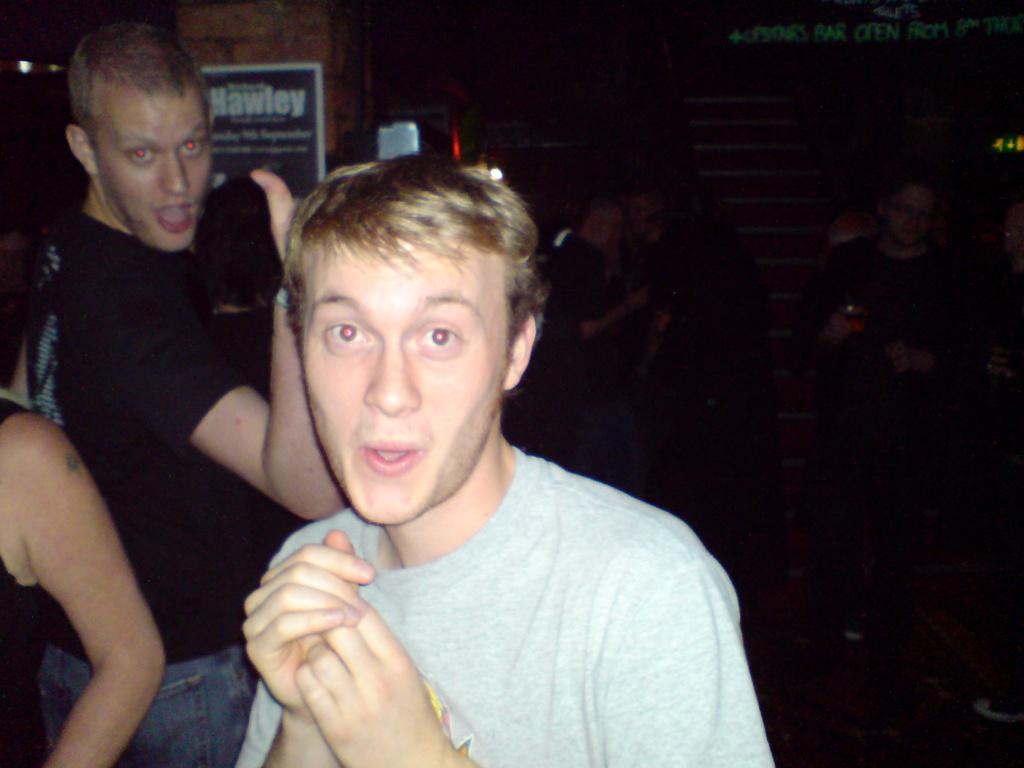In one or two sentences, can you explain what this image depicts? In this picture there are group of people standing. At the back there is a board on the wall and there is text on the board. At the top right there is text. At the bottom it looks like a mat on the floor. 